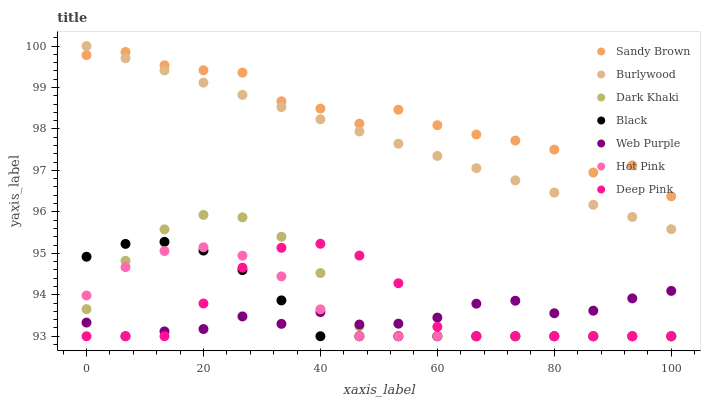Does Web Purple have the minimum area under the curve?
Answer yes or no. Yes. Does Sandy Brown have the maximum area under the curve?
Answer yes or no. Yes. Does Burlywood have the minimum area under the curve?
Answer yes or no. No. Does Burlywood have the maximum area under the curve?
Answer yes or no. No. Is Burlywood the smoothest?
Answer yes or no. Yes. Is Sandy Brown the roughest?
Answer yes or no. Yes. Is Hot Pink the smoothest?
Answer yes or no. No. Is Hot Pink the roughest?
Answer yes or no. No. Does Deep Pink have the lowest value?
Answer yes or no. Yes. Does Burlywood have the lowest value?
Answer yes or no. No. Does Burlywood have the highest value?
Answer yes or no. Yes. Does Hot Pink have the highest value?
Answer yes or no. No. Is Black less than Burlywood?
Answer yes or no. Yes. Is Burlywood greater than Black?
Answer yes or no. Yes. Does Deep Pink intersect Black?
Answer yes or no. Yes. Is Deep Pink less than Black?
Answer yes or no. No. Is Deep Pink greater than Black?
Answer yes or no. No. Does Black intersect Burlywood?
Answer yes or no. No. 